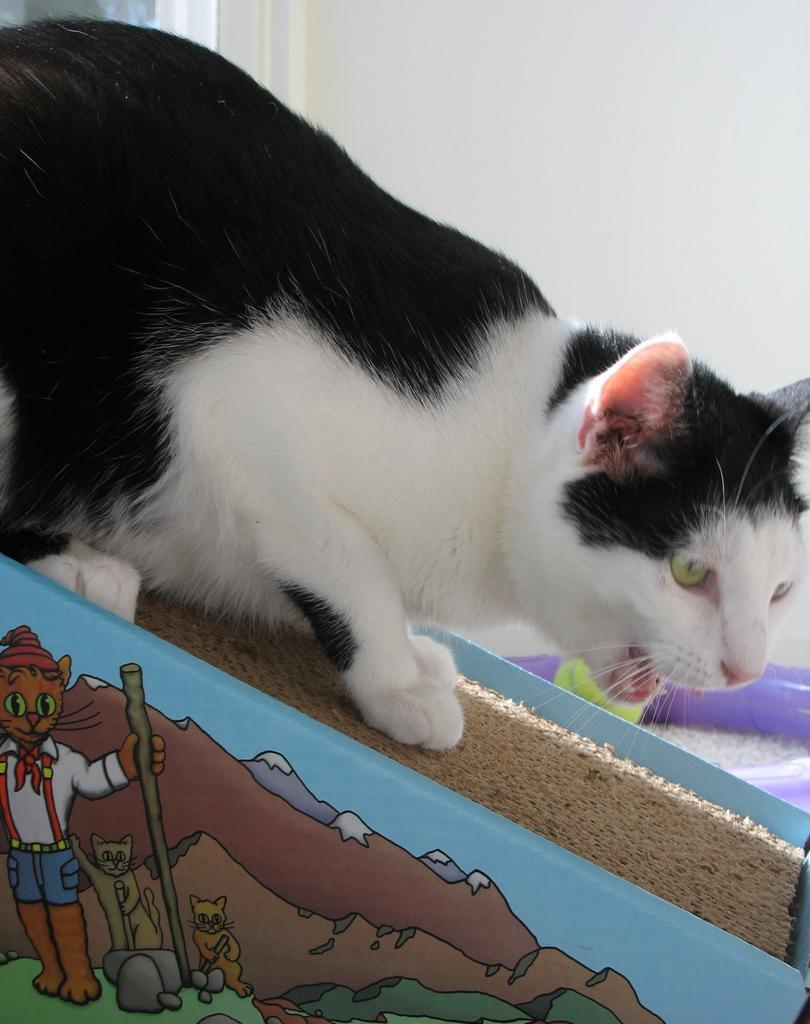Describe this image in one or two sentences. In this image we can see a cat which is in black and white color is on the surface and we can see some paintings and in the background of the image there is a wall. 